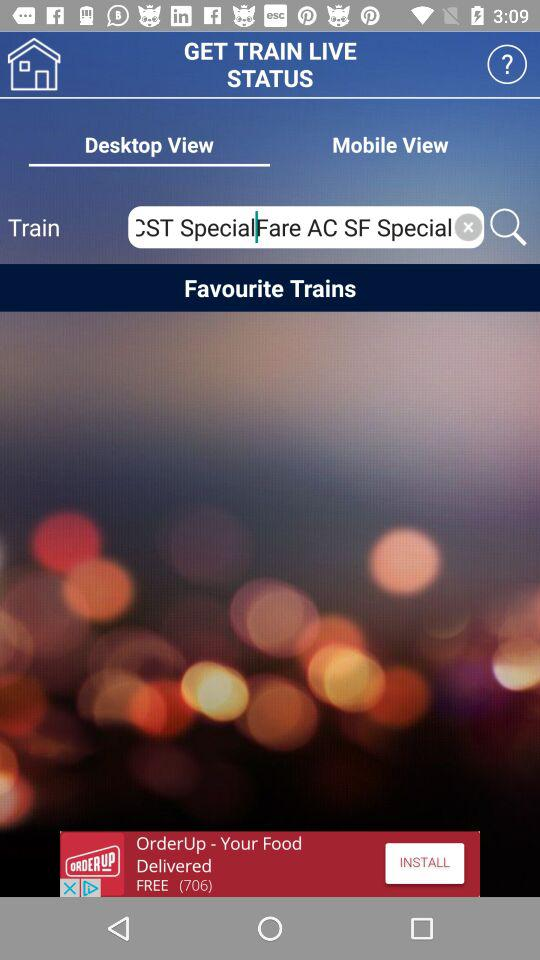Which trains are selected as favorites?
When the provided information is insufficient, respond with <no answer>. <no answer> 